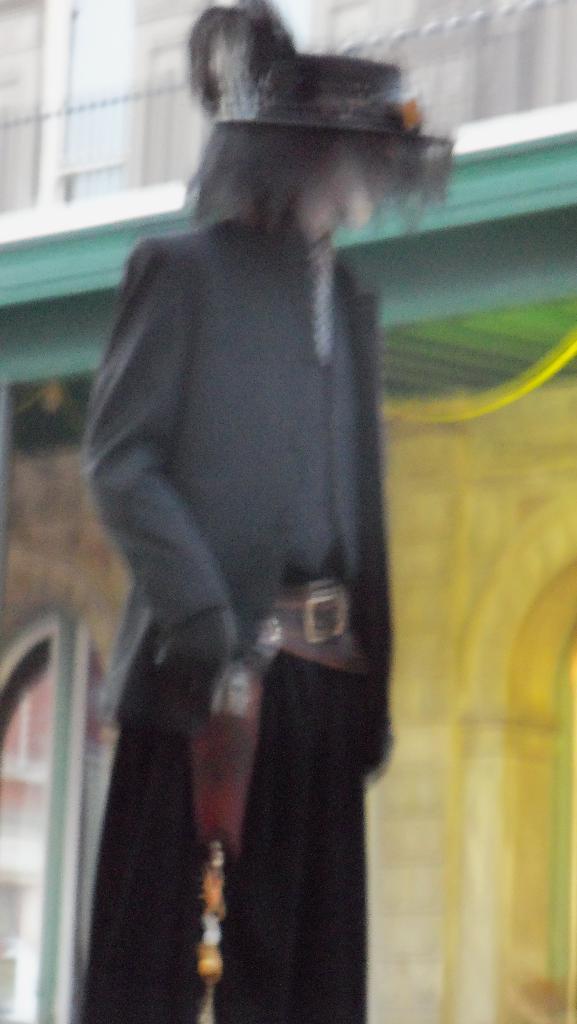Describe this image in one or two sentences. In this picture we can see a blur image of something. 